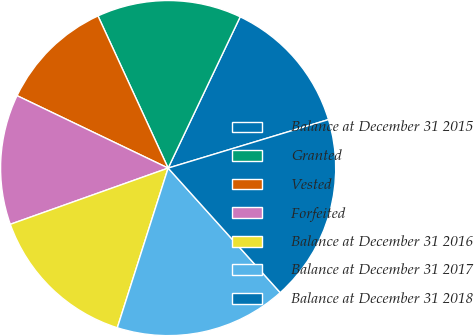<chart> <loc_0><loc_0><loc_500><loc_500><pie_chart><fcel>Balance at December 31 2015<fcel>Granted<fcel>Vested<fcel>Forfeited<fcel>Balance at December 31 2016<fcel>Balance at December 31 2017<fcel>Balance at December 31 2018<nl><fcel>13.25%<fcel>13.95%<fcel>11.01%<fcel>12.56%<fcel>14.65%<fcel>16.57%<fcel>18.01%<nl></chart> 